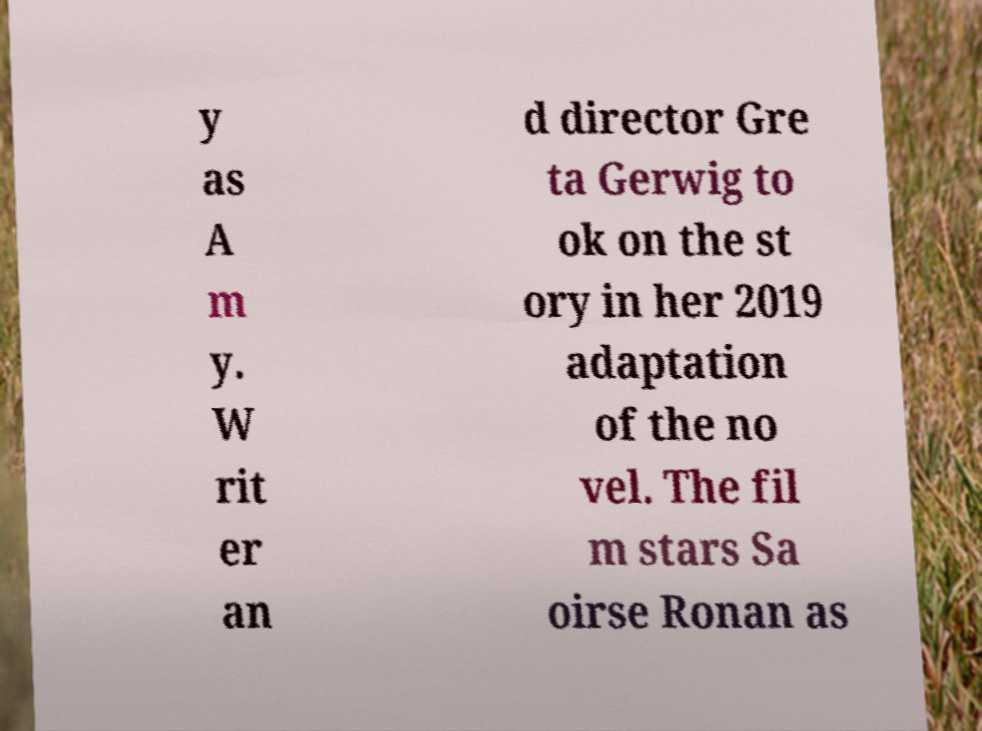I need the written content from this picture converted into text. Can you do that? y as A m y. W rit er an d director Gre ta Gerwig to ok on the st ory in her 2019 adaptation of the no vel. The fil m stars Sa oirse Ronan as 